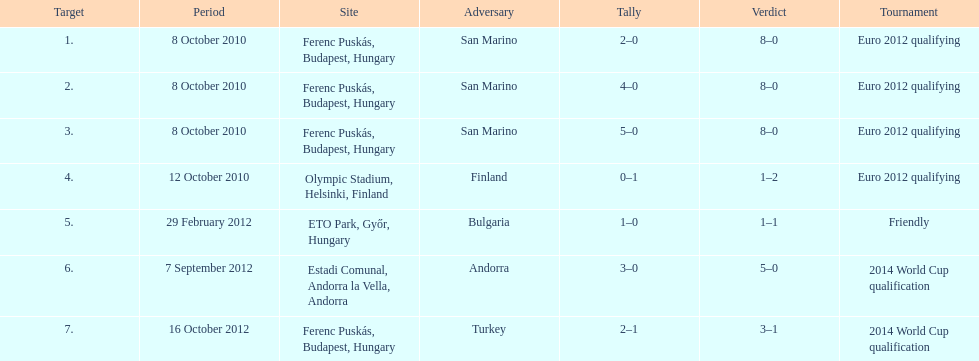In what year was szalai's first international goal? 2010. 